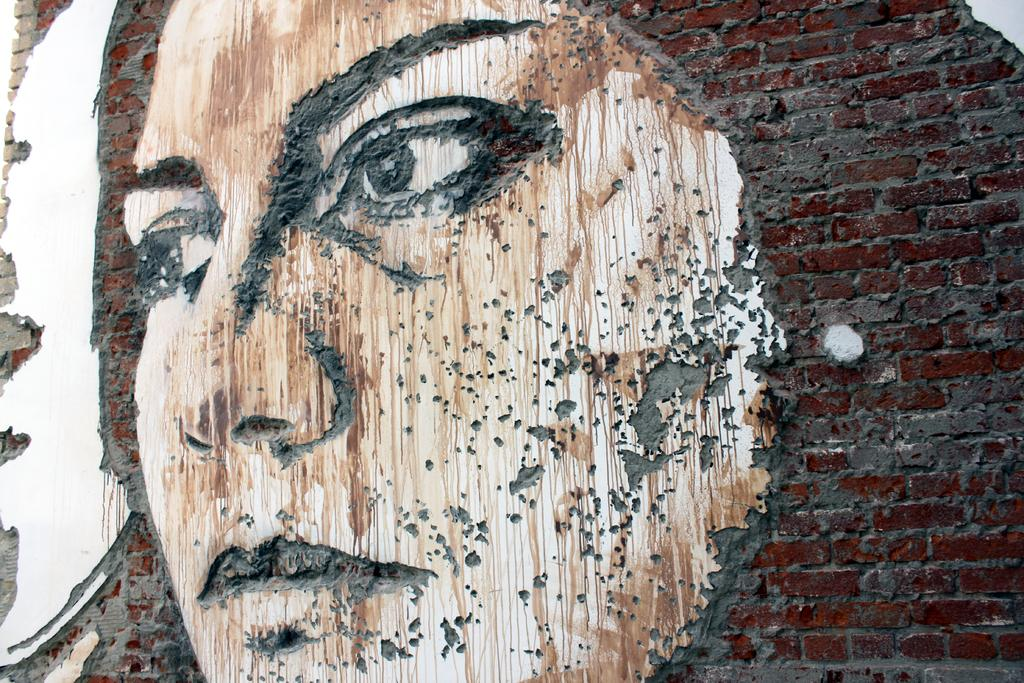What is depicted on the wall in the image? There is a face of a person on the wall in the image. How does the beetle contribute to the earthquake in the image? There is no beetle or earthquake present in the image; it only features the face of a person on the wall. 